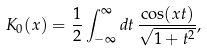<formula> <loc_0><loc_0><loc_500><loc_500>K _ { 0 } ( x ) = \frac { 1 } { 2 } \int _ { - \infty } ^ { \infty } d t \, \frac { \cos ( x t ) } { \sqrt { 1 + t ^ { 2 } } } ,</formula> 